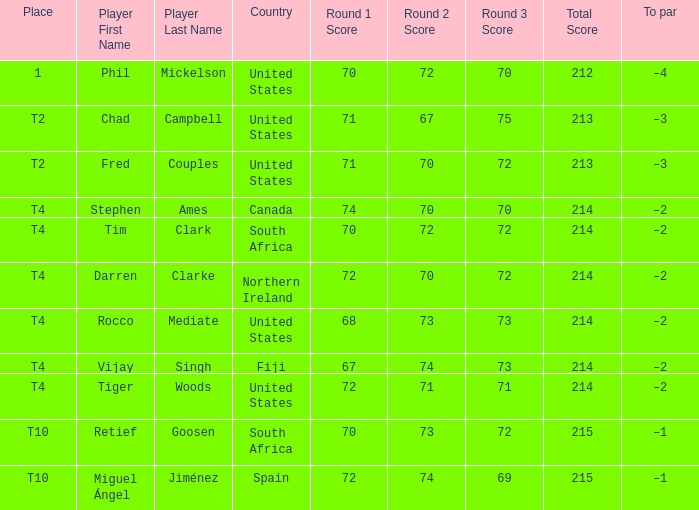What is Rocco Mediate's par? –2. 